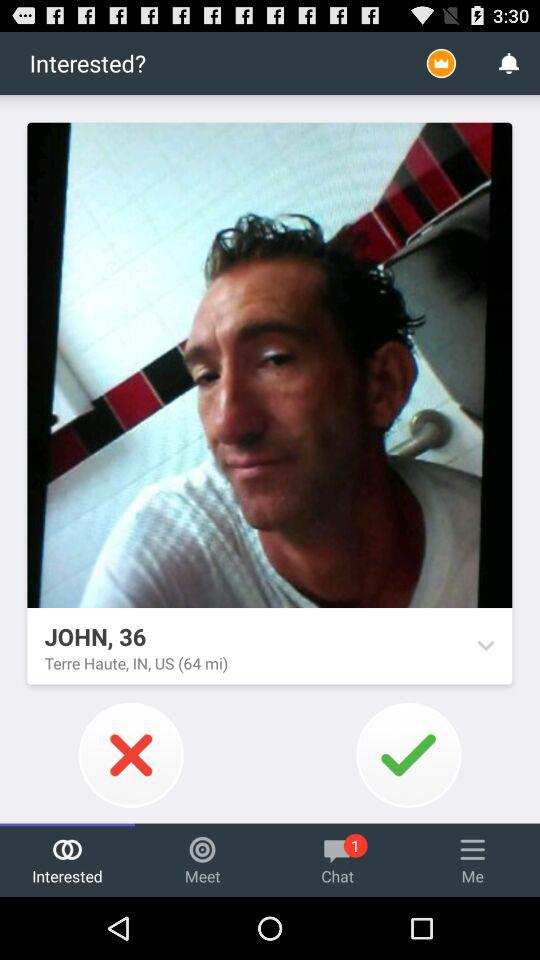Where is John from? John is from Terre Haute, Indiana, US. 